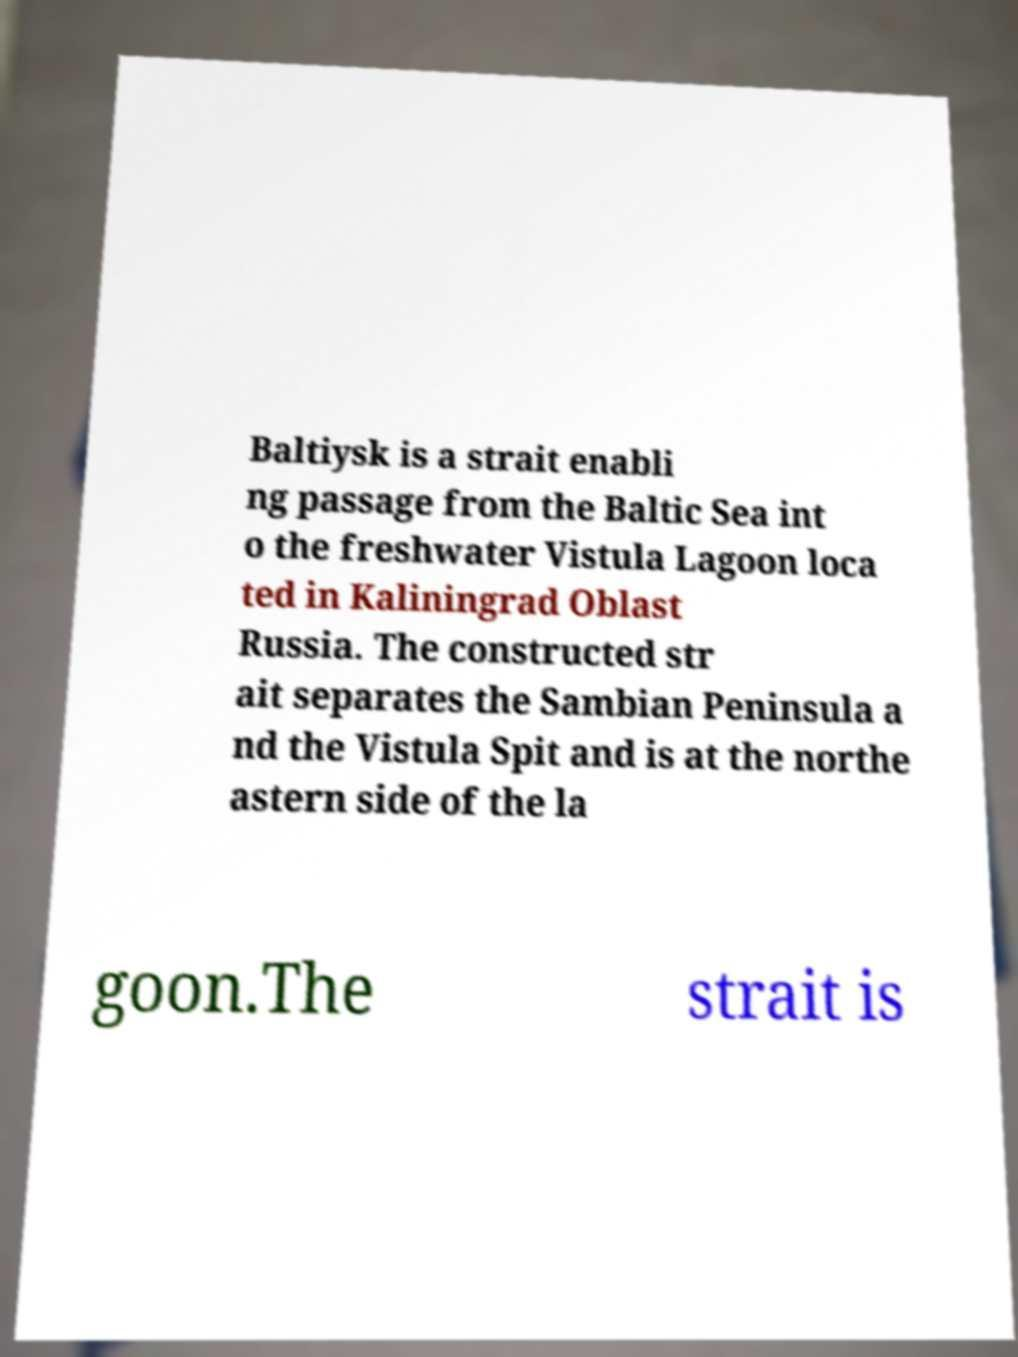Please identify and transcribe the text found in this image. Baltiysk is a strait enabli ng passage from the Baltic Sea int o the freshwater Vistula Lagoon loca ted in Kaliningrad Oblast Russia. The constructed str ait separates the Sambian Peninsula a nd the Vistula Spit and is at the northe astern side of the la goon.The strait is 